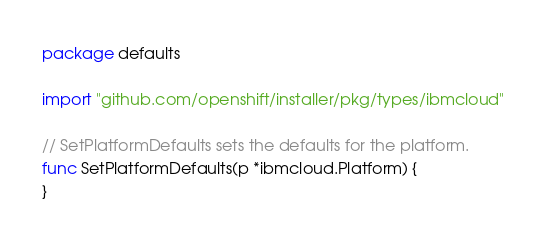<code> <loc_0><loc_0><loc_500><loc_500><_Go_>package defaults

import "github.com/openshift/installer/pkg/types/ibmcloud"

// SetPlatformDefaults sets the defaults for the platform.
func SetPlatformDefaults(p *ibmcloud.Platform) {
}
</code> 